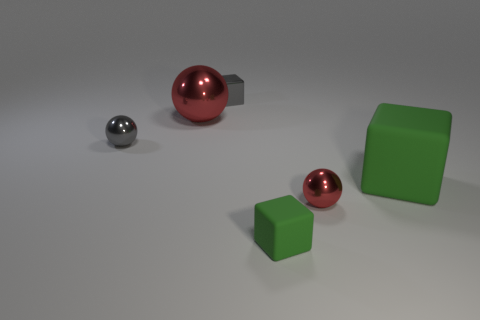Subtract all purple spheres. Subtract all blue cylinders. How many spheres are left? 3 Add 3 big green matte objects. How many objects exist? 9 Subtract all small blue shiny cylinders. Subtract all large red objects. How many objects are left? 5 Add 6 tiny objects. How many tiny objects are left? 10 Add 2 small metal balls. How many small metal balls exist? 4 Subtract 0 yellow cubes. How many objects are left? 6 